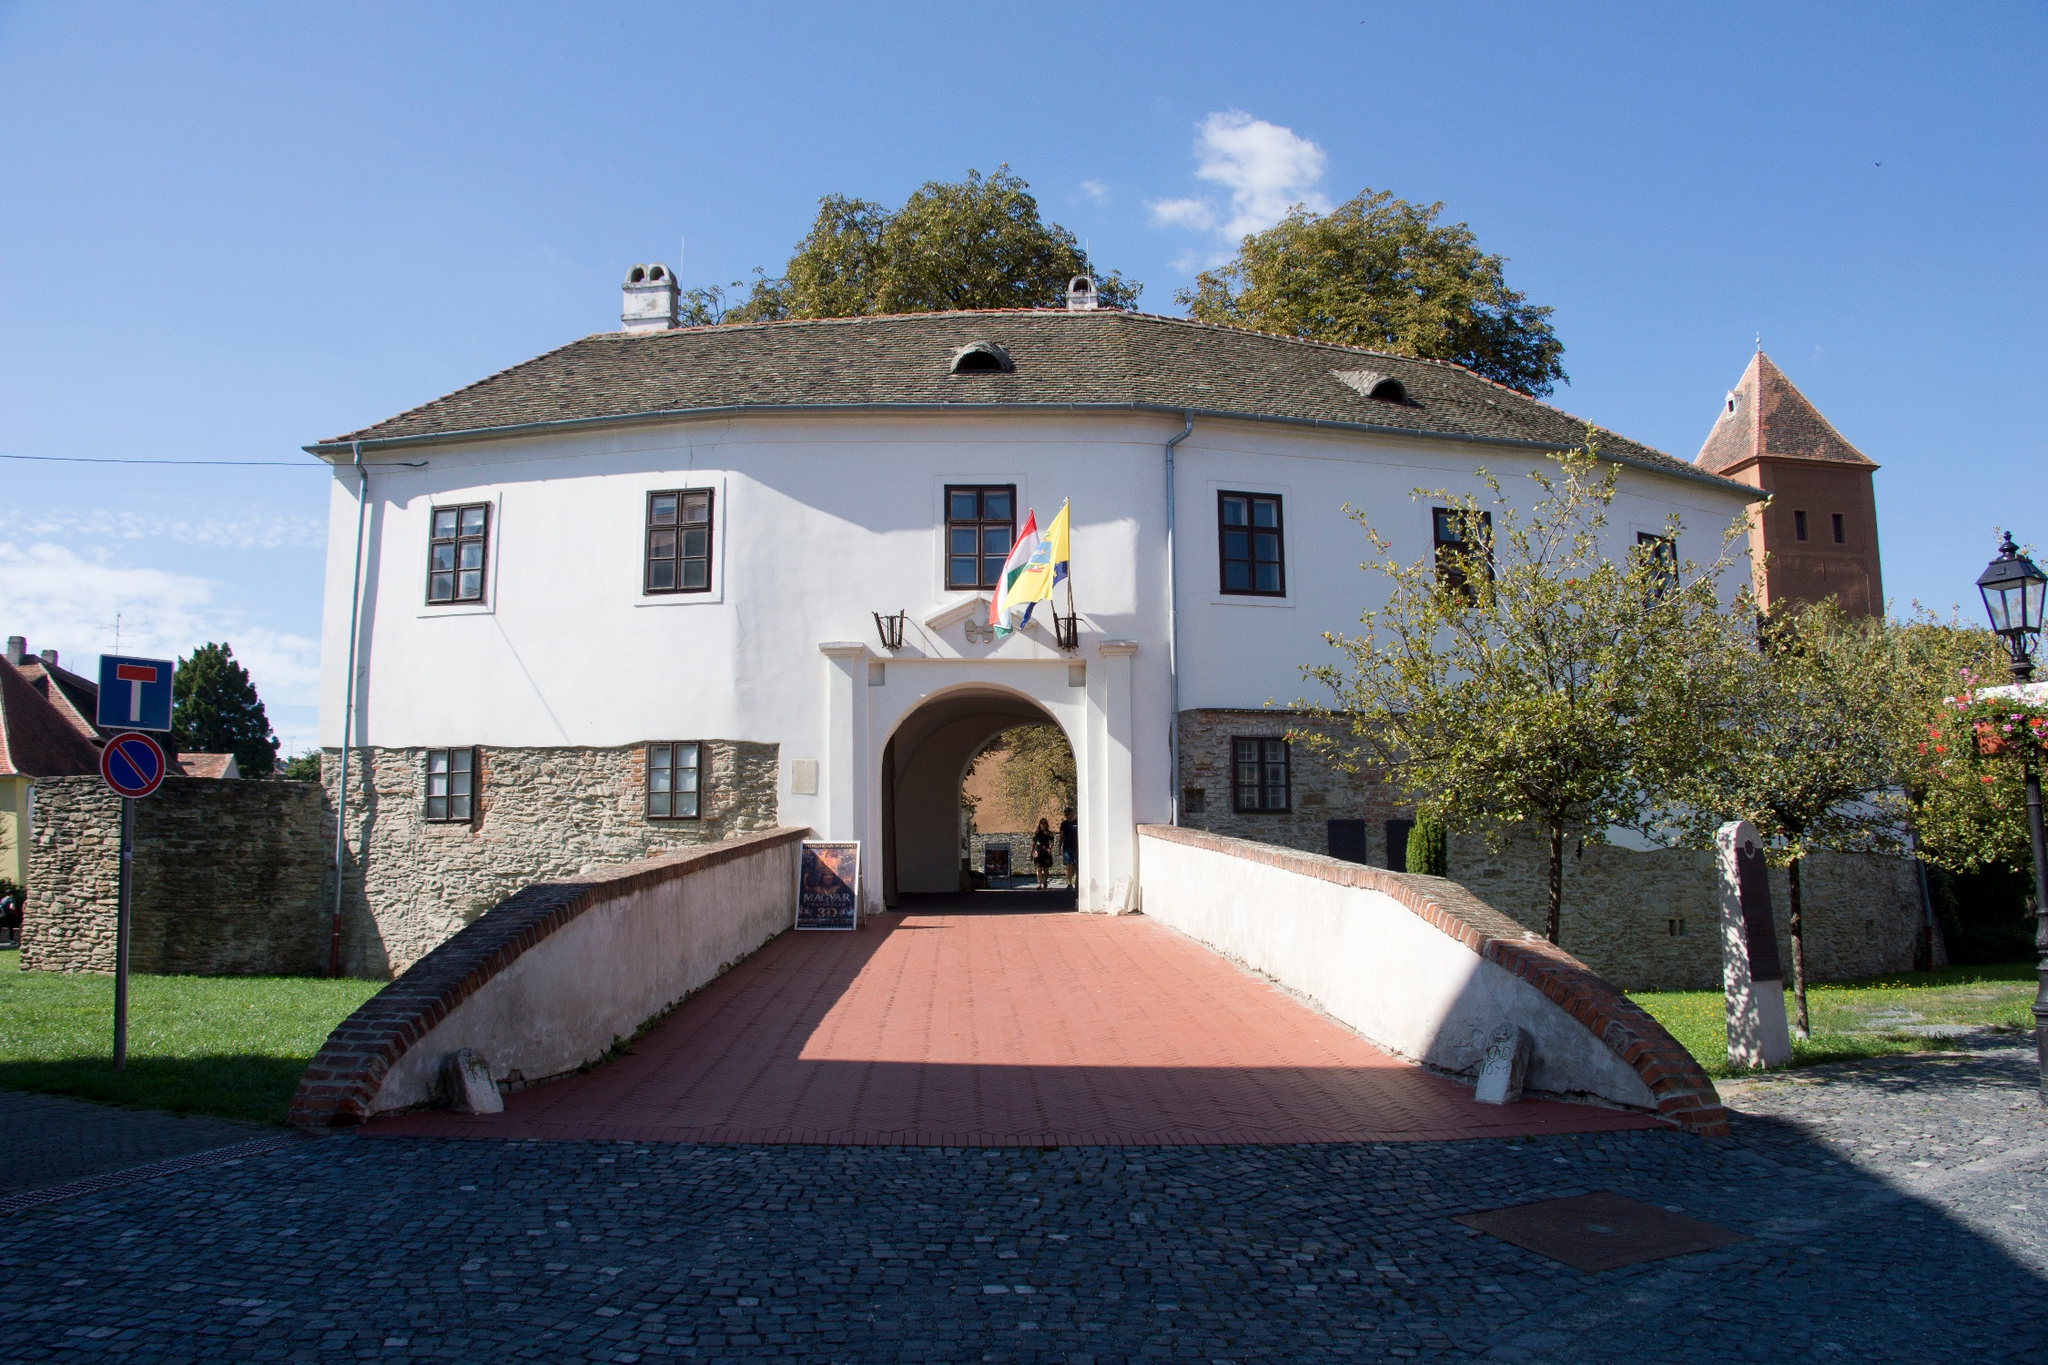Analyze the image in a comprehensive and detailed manner. The image portrays the entrance to a historical and architectural landmark, the fortified church located in Prejmer, Romania. The entryway is framed by a sturdy, white-walled building crowned with a traditional red-tiled roof. This structure features a modest tower that rises above the main roofline and is further encapsulated by a formidable stone wall characteristic of fortified constructions. A red brick walkway adds a vivid touch amidst the lush greenery, leading visitors directly into the welcoming archway of the building. The scene is bathed in natural sunlight under a clear, azure sky, creating a picturesque backdrop. In this tranquil setting, a solitary street lamp and surrounding verdant foliage complement the tranquil yet historic ambiance of the site. The image, identified as 'sa_1608', encapsulates not only the architectural grandeur but also the serene environment of this Romanian heritage site, making it a captivating glimpse into the past. 